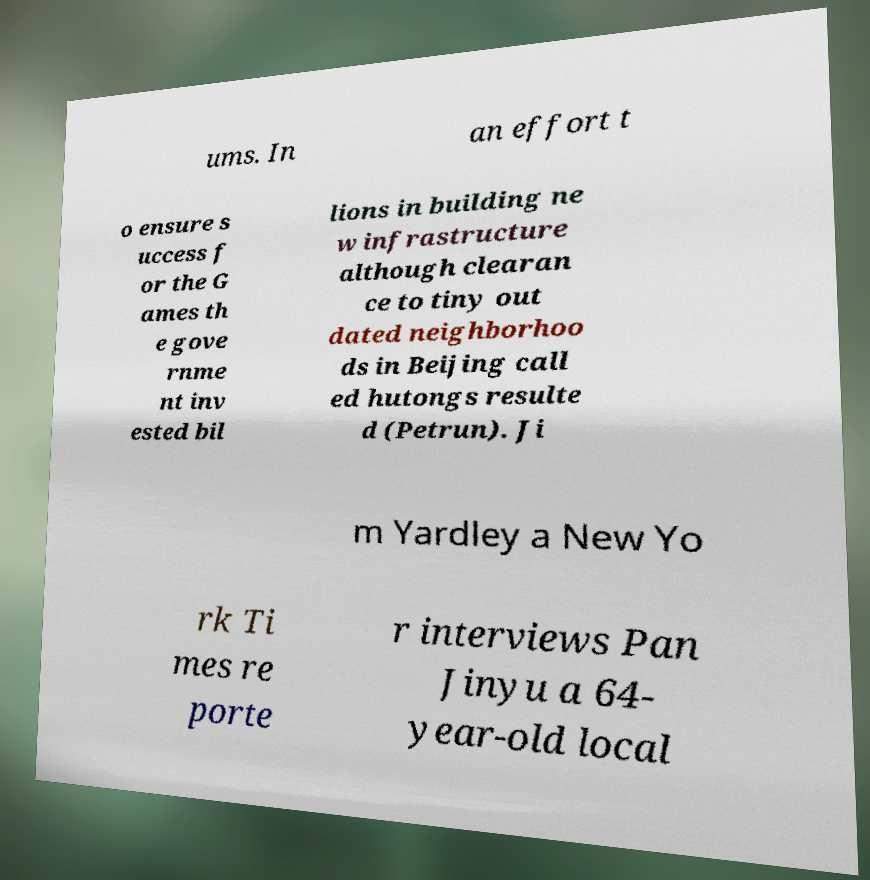What messages or text are displayed in this image? I need them in a readable, typed format. ums. In an effort t o ensure s uccess f or the G ames th e gove rnme nt inv ested bil lions in building ne w infrastructure although clearan ce to tiny out dated neighborhoo ds in Beijing call ed hutongs resulte d (Petrun). Ji m Yardley a New Yo rk Ti mes re porte r interviews Pan Jinyu a 64- year-old local 